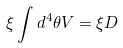<formula> <loc_0><loc_0><loc_500><loc_500>\xi \int d ^ { 4 } \theta V = \xi D</formula> 